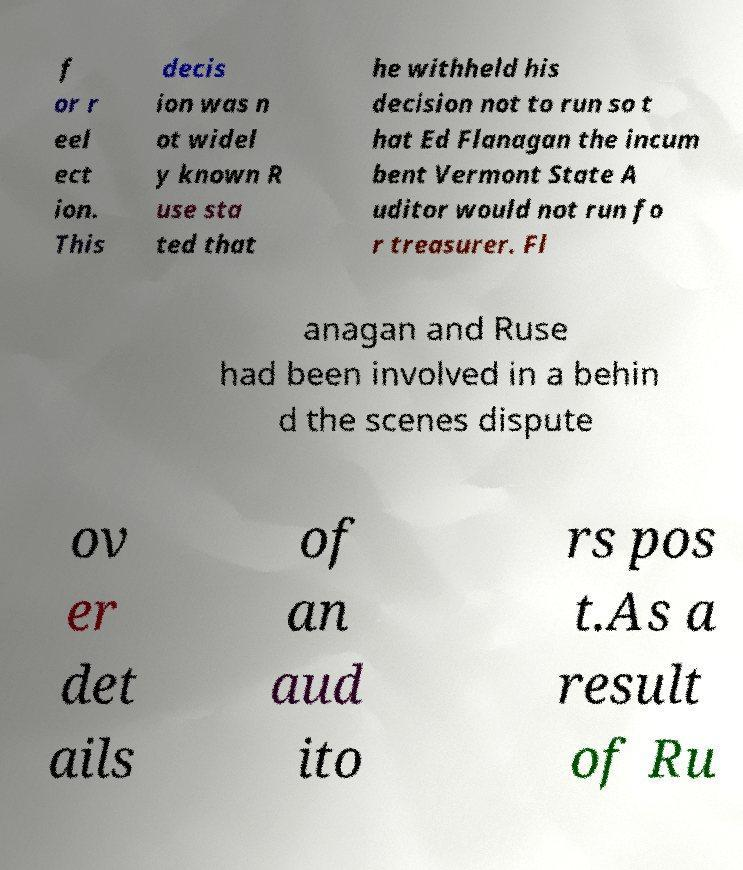For documentation purposes, I need the text within this image transcribed. Could you provide that? f or r eel ect ion. This decis ion was n ot widel y known R use sta ted that he withheld his decision not to run so t hat Ed Flanagan the incum bent Vermont State A uditor would not run fo r treasurer. Fl anagan and Ruse had been involved in a behin d the scenes dispute ov er det ails of an aud ito rs pos t.As a result of Ru 